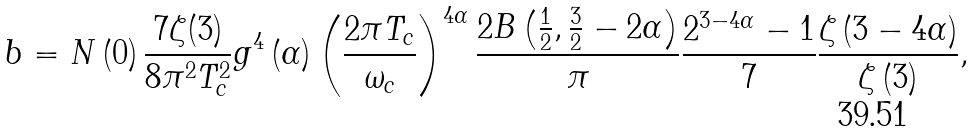Convert formula to latex. <formula><loc_0><loc_0><loc_500><loc_500>b = N \left ( 0 \right ) \frac { 7 \zeta ( 3 ) } { 8 \pi ^ { 2 } T _ { c } ^ { 2 } } g ^ { 4 } \left ( \alpha \right ) \left ( \frac { 2 \pi T _ { c } } { \omega _ { c } } \right ) ^ { 4 \alpha } \frac { 2 B \left ( \frac { 1 } { 2 } , \frac { 3 } { 2 } - 2 \alpha \right ) } \pi \frac { 2 ^ { 3 - 4 \alpha } - 1 } 7 \frac { \zeta \left ( 3 - 4 \alpha \right ) } { \zeta \left ( 3 \right ) } ,</formula> 